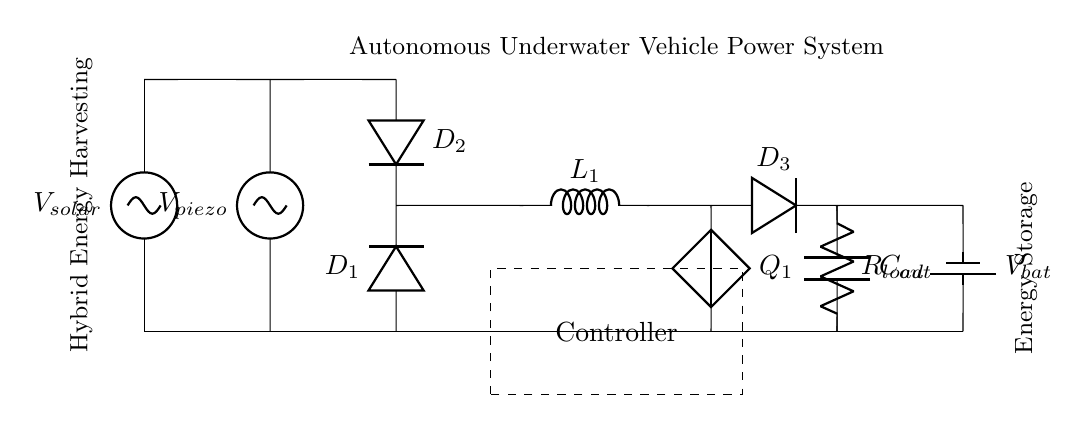What are the main components used in this circuit? The circuit contains a solar panel, a piezoelectric generator, a rectifier with two diodes, a boost converter with an inductor and a diode, a capacitor, a load resistor, a battery, and a controller.
Answer: Solar panel, piezoelectric generator, diodes, inductor, capacitor, load resistor, battery, controller What type of energy does the piezoelectric generator produce? The piezoelectric generator transforms mechanical energy into electrical energy, typically from vibrations or pressure changes.
Answer: Electrical energy What is the role of the diodes in this circuit? The diodes are primarily used for rectification, allowing current to flow in one direction, which helps convert AC current from the generators into DC current suitable for storage and use.
Answer: Rectification How many energy sources are present in this circuit? There are two energy sources: one is the solar panel, and the other is the piezoelectric generator.
Answer: Two What function does the boost converter serve in the circuit? The boost converter steps up the voltage from the generators to a higher level, allowing effective operation of the load and battery charging even if the input voltage is low.
Answer: Voltage conversion What is the purpose of the output capacitor in this energy harvesting circuit? The output capacitor stabilizes the voltage and provides a constant flow of energy to the load, compensating for fluctuations in power generation conditions.
Answer: Stabilization Which component stores energy temporarily in the circuit? The capacitor stores energy temporarily and helps smooth the output voltage for the load during operation.
Answer: Capacitor 